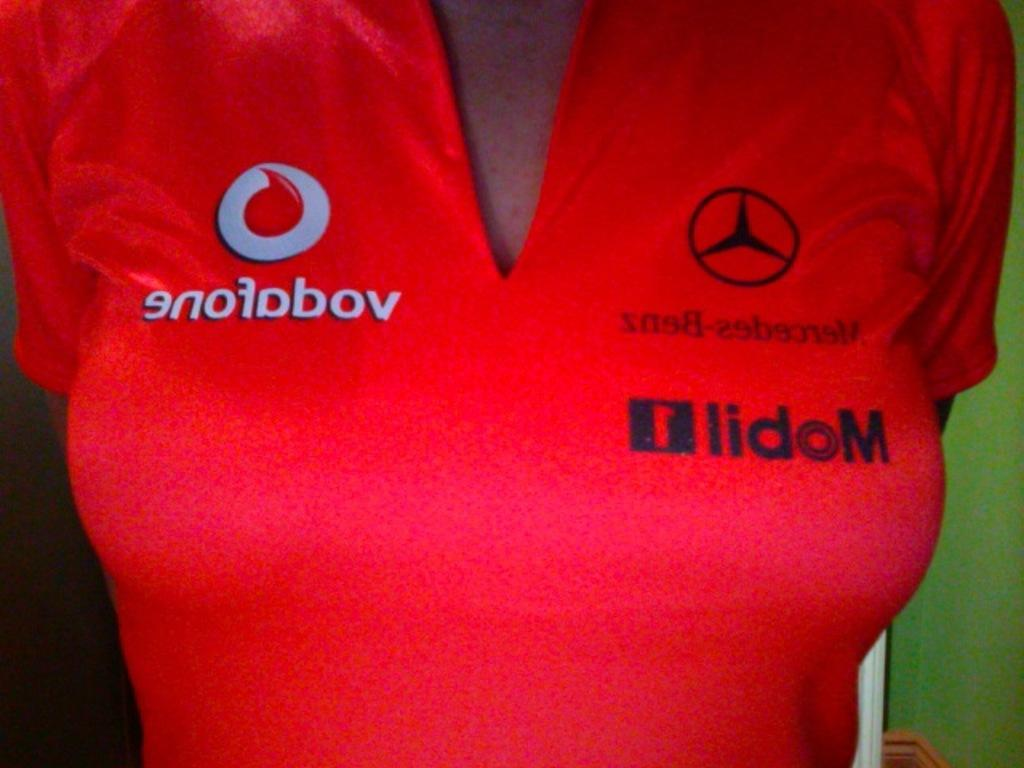<image>
Render a clear and concise summary of the photo. Women's shirt that is red and it says Mobile 1 Mercedes Benz for racing. 